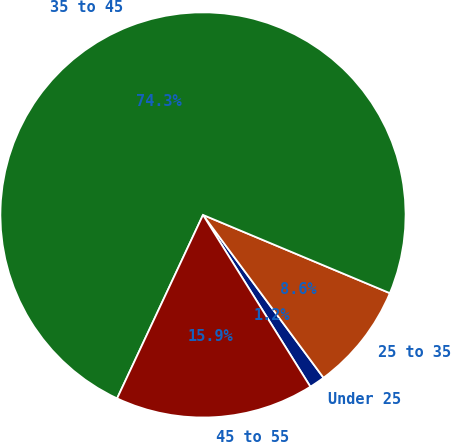<chart> <loc_0><loc_0><loc_500><loc_500><pie_chart><fcel>Under 25<fcel>25 to 35<fcel>35 to 45<fcel>45 to 55<nl><fcel>1.25%<fcel>8.55%<fcel>74.34%<fcel>15.86%<nl></chart> 